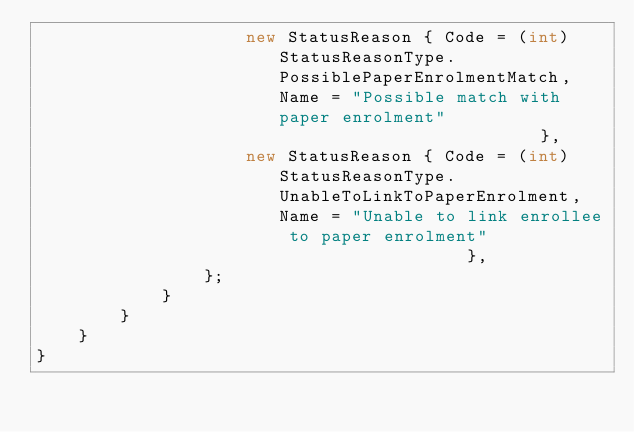<code> <loc_0><loc_0><loc_500><loc_500><_C#_>                    new StatusReason { Code = (int)StatusReasonType.PossiblePaperEnrolmentMatch,  Name = "Possible match with paper enrolment"                          },
                    new StatusReason { Code = (int)StatusReasonType.UnableToLinkToPaperEnrolment, Name = "Unable to link enrollee to paper enrolment"                   },
                };
            }
        }
    }
}
</code> 